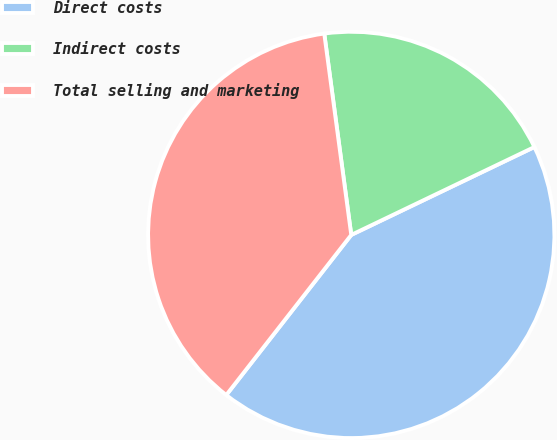Convert chart. <chart><loc_0><loc_0><loc_500><loc_500><pie_chart><fcel>Direct costs<fcel>Indirect costs<fcel>Total selling and marketing<nl><fcel>42.67%<fcel>20.0%<fcel>37.33%<nl></chart> 